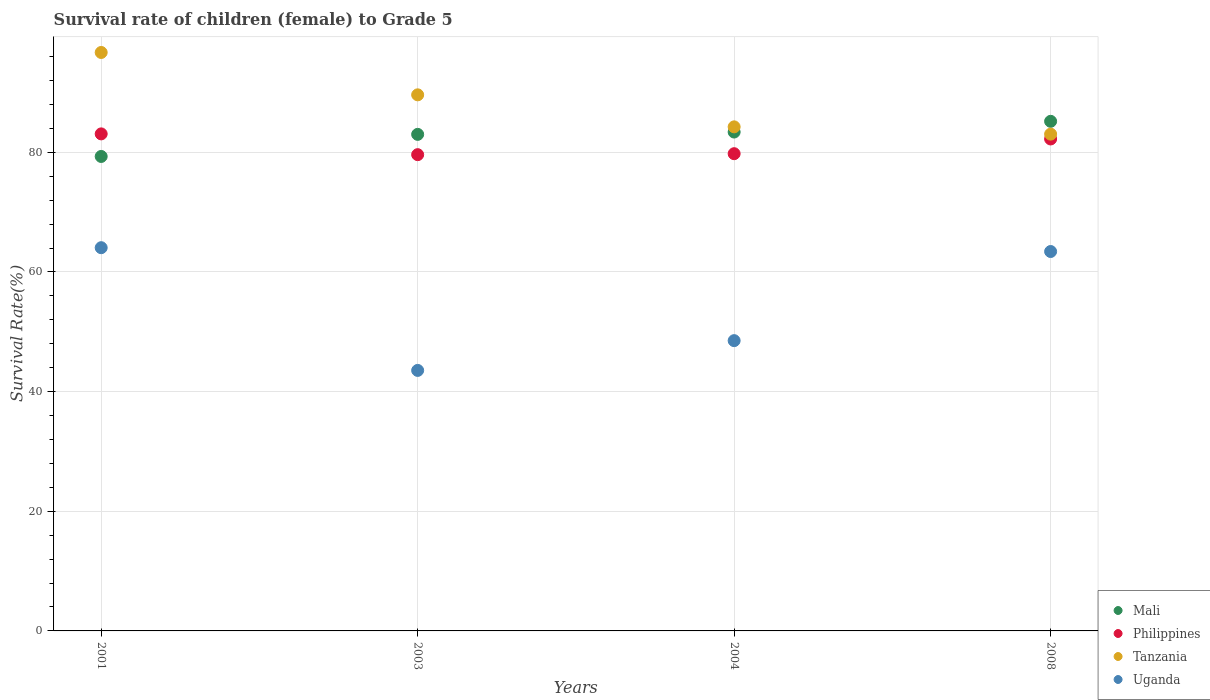How many different coloured dotlines are there?
Your response must be concise. 4. What is the survival rate of female children to grade 5 in Tanzania in 2008?
Offer a very short reply. 83.03. Across all years, what is the maximum survival rate of female children to grade 5 in Mali?
Make the answer very short. 85.18. Across all years, what is the minimum survival rate of female children to grade 5 in Philippines?
Provide a short and direct response. 79.6. In which year was the survival rate of female children to grade 5 in Uganda minimum?
Ensure brevity in your answer.  2003. What is the total survival rate of female children to grade 5 in Uganda in the graph?
Keep it short and to the point. 219.53. What is the difference between the survival rate of female children to grade 5 in Tanzania in 2003 and that in 2008?
Your response must be concise. 6.57. What is the difference between the survival rate of female children to grade 5 in Philippines in 2004 and the survival rate of female children to grade 5 in Uganda in 2003?
Provide a short and direct response. 36.22. What is the average survival rate of female children to grade 5 in Uganda per year?
Ensure brevity in your answer.  54.88. In the year 2003, what is the difference between the survival rate of female children to grade 5 in Tanzania and survival rate of female children to grade 5 in Mali?
Offer a terse response. 6.61. What is the ratio of the survival rate of female children to grade 5 in Uganda in 2004 to that in 2008?
Your answer should be very brief. 0.77. Is the survival rate of female children to grade 5 in Tanzania in 2003 less than that in 2004?
Offer a terse response. No. Is the difference between the survival rate of female children to grade 5 in Tanzania in 2001 and 2004 greater than the difference between the survival rate of female children to grade 5 in Mali in 2001 and 2004?
Your answer should be very brief. Yes. What is the difference between the highest and the second highest survival rate of female children to grade 5 in Uganda?
Your answer should be compact. 0.64. What is the difference between the highest and the lowest survival rate of female children to grade 5 in Philippines?
Your answer should be compact. 3.47. In how many years, is the survival rate of female children to grade 5 in Uganda greater than the average survival rate of female children to grade 5 in Uganda taken over all years?
Ensure brevity in your answer.  2. Is it the case that in every year, the sum of the survival rate of female children to grade 5 in Philippines and survival rate of female children to grade 5 in Uganda  is greater than the survival rate of female children to grade 5 in Mali?
Provide a short and direct response. Yes. Is the survival rate of female children to grade 5 in Uganda strictly less than the survival rate of female children to grade 5 in Tanzania over the years?
Make the answer very short. Yes. How many dotlines are there?
Make the answer very short. 4. How many years are there in the graph?
Your response must be concise. 4. What is the difference between two consecutive major ticks on the Y-axis?
Offer a terse response. 20. Are the values on the major ticks of Y-axis written in scientific E-notation?
Provide a short and direct response. No. How many legend labels are there?
Provide a succinct answer. 4. What is the title of the graph?
Give a very brief answer. Survival rate of children (female) to Grade 5. Does "Mauritius" appear as one of the legend labels in the graph?
Provide a short and direct response. No. What is the label or title of the X-axis?
Keep it short and to the point. Years. What is the label or title of the Y-axis?
Offer a terse response. Survival Rate(%). What is the Survival Rate(%) in Mali in 2001?
Your answer should be compact. 79.3. What is the Survival Rate(%) of Philippines in 2001?
Offer a very short reply. 83.08. What is the Survival Rate(%) of Tanzania in 2001?
Give a very brief answer. 96.68. What is the Survival Rate(%) in Uganda in 2001?
Offer a very short reply. 64.05. What is the Survival Rate(%) in Mali in 2003?
Your answer should be very brief. 83. What is the Survival Rate(%) in Philippines in 2003?
Give a very brief answer. 79.6. What is the Survival Rate(%) in Tanzania in 2003?
Offer a terse response. 89.6. What is the Survival Rate(%) in Uganda in 2003?
Provide a succinct answer. 43.54. What is the Survival Rate(%) of Mali in 2004?
Give a very brief answer. 83.38. What is the Survival Rate(%) in Philippines in 2004?
Offer a terse response. 79.77. What is the Survival Rate(%) of Tanzania in 2004?
Offer a terse response. 84.25. What is the Survival Rate(%) in Uganda in 2004?
Keep it short and to the point. 48.52. What is the Survival Rate(%) in Mali in 2008?
Provide a succinct answer. 85.18. What is the Survival Rate(%) of Philippines in 2008?
Your response must be concise. 82.23. What is the Survival Rate(%) in Tanzania in 2008?
Give a very brief answer. 83.03. What is the Survival Rate(%) in Uganda in 2008?
Ensure brevity in your answer.  63.41. Across all years, what is the maximum Survival Rate(%) in Mali?
Provide a succinct answer. 85.18. Across all years, what is the maximum Survival Rate(%) of Philippines?
Offer a terse response. 83.08. Across all years, what is the maximum Survival Rate(%) in Tanzania?
Offer a terse response. 96.68. Across all years, what is the maximum Survival Rate(%) in Uganda?
Your answer should be very brief. 64.05. Across all years, what is the minimum Survival Rate(%) of Mali?
Offer a terse response. 79.3. Across all years, what is the minimum Survival Rate(%) in Philippines?
Provide a short and direct response. 79.6. Across all years, what is the minimum Survival Rate(%) of Tanzania?
Your answer should be very brief. 83.03. Across all years, what is the minimum Survival Rate(%) of Uganda?
Offer a terse response. 43.54. What is the total Survival Rate(%) in Mali in the graph?
Your answer should be compact. 330.86. What is the total Survival Rate(%) of Philippines in the graph?
Give a very brief answer. 324.67. What is the total Survival Rate(%) in Tanzania in the graph?
Provide a short and direct response. 353.57. What is the total Survival Rate(%) in Uganda in the graph?
Your answer should be compact. 219.53. What is the difference between the Survival Rate(%) in Mali in 2001 and that in 2003?
Ensure brevity in your answer.  -3.69. What is the difference between the Survival Rate(%) of Philippines in 2001 and that in 2003?
Your response must be concise. 3.47. What is the difference between the Survival Rate(%) in Tanzania in 2001 and that in 2003?
Offer a very short reply. 7.08. What is the difference between the Survival Rate(%) of Uganda in 2001 and that in 2003?
Give a very brief answer. 20.51. What is the difference between the Survival Rate(%) in Mali in 2001 and that in 2004?
Offer a very short reply. -4.08. What is the difference between the Survival Rate(%) of Philippines in 2001 and that in 2004?
Make the answer very short. 3.31. What is the difference between the Survival Rate(%) of Tanzania in 2001 and that in 2004?
Provide a short and direct response. 12.43. What is the difference between the Survival Rate(%) of Uganda in 2001 and that in 2004?
Make the answer very short. 15.54. What is the difference between the Survival Rate(%) in Mali in 2001 and that in 2008?
Make the answer very short. -5.87. What is the difference between the Survival Rate(%) of Philippines in 2001 and that in 2008?
Your answer should be very brief. 0.85. What is the difference between the Survival Rate(%) in Tanzania in 2001 and that in 2008?
Offer a very short reply. 13.65. What is the difference between the Survival Rate(%) in Uganda in 2001 and that in 2008?
Offer a terse response. 0.64. What is the difference between the Survival Rate(%) of Mali in 2003 and that in 2004?
Ensure brevity in your answer.  -0.39. What is the difference between the Survival Rate(%) of Philippines in 2003 and that in 2004?
Your answer should be compact. -0.16. What is the difference between the Survival Rate(%) of Tanzania in 2003 and that in 2004?
Your answer should be very brief. 5.35. What is the difference between the Survival Rate(%) in Uganda in 2003 and that in 2004?
Your answer should be very brief. -4.98. What is the difference between the Survival Rate(%) in Mali in 2003 and that in 2008?
Offer a terse response. -2.18. What is the difference between the Survival Rate(%) in Philippines in 2003 and that in 2008?
Your answer should be compact. -2.62. What is the difference between the Survival Rate(%) of Tanzania in 2003 and that in 2008?
Offer a very short reply. 6.57. What is the difference between the Survival Rate(%) of Uganda in 2003 and that in 2008?
Give a very brief answer. -19.87. What is the difference between the Survival Rate(%) of Mali in 2004 and that in 2008?
Keep it short and to the point. -1.79. What is the difference between the Survival Rate(%) in Philippines in 2004 and that in 2008?
Keep it short and to the point. -2.46. What is the difference between the Survival Rate(%) in Tanzania in 2004 and that in 2008?
Offer a very short reply. 1.22. What is the difference between the Survival Rate(%) in Uganda in 2004 and that in 2008?
Your response must be concise. -14.9. What is the difference between the Survival Rate(%) of Mali in 2001 and the Survival Rate(%) of Philippines in 2003?
Keep it short and to the point. -0.3. What is the difference between the Survival Rate(%) of Mali in 2001 and the Survival Rate(%) of Tanzania in 2003?
Your answer should be compact. -10.3. What is the difference between the Survival Rate(%) of Mali in 2001 and the Survival Rate(%) of Uganda in 2003?
Your response must be concise. 35.76. What is the difference between the Survival Rate(%) of Philippines in 2001 and the Survival Rate(%) of Tanzania in 2003?
Offer a terse response. -6.53. What is the difference between the Survival Rate(%) of Philippines in 2001 and the Survival Rate(%) of Uganda in 2003?
Provide a succinct answer. 39.53. What is the difference between the Survival Rate(%) of Tanzania in 2001 and the Survival Rate(%) of Uganda in 2003?
Make the answer very short. 53.14. What is the difference between the Survival Rate(%) of Mali in 2001 and the Survival Rate(%) of Philippines in 2004?
Your answer should be very brief. -0.46. What is the difference between the Survival Rate(%) in Mali in 2001 and the Survival Rate(%) in Tanzania in 2004?
Your answer should be very brief. -4.95. What is the difference between the Survival Rate(%) of Mali in 2001 and the Survival Rate(%) of Uganda in 2004?
Provide a succinct answer. 30.78. What is the difference between the Survival Rate(%) of Philippines in 2001 and the Survival Rate(%) of Tanzania in 2004?
Provide a succinct answer. -1.18. What is the difference between the Survival Rate(%) in Philippines in 2001 and the Survival Rate(%) in Uganda in 2004?
Your answer should be compact. 34.56. What is the difference between the Survival Rate(%) of Tanzania in 2001 and the Survival Rate(%) of Uganda in 2004?
Give a very brief answer. 48.17. What is the difference between the Survival Rate(%) in Mali in 2001 and the Survival Rate(%) in Philippines in 2008?
Provide a short and direct response. -2.92. What is the difference between the Survival Rate(%) of Mali in 2001 and the Survival Rate(%) of Tanzania in 2008?
Offer a very short reply. -3.73. What is the difference between the Survival Rate(%) in Mali in 2001 and the Survival Rate(%) in Uganda in 2008?
Keep it short and to the point. 15.89. What is the difference between the Survival Rate(%) of Philippines in 2001 and the Survival Rate(%) of Tanzania in 2008?
Provide a succinct answer. 0.04. What is the difference between the Survival Rate(%) of Philippines in 2001 and the Survival Rate(%) of Uganda in 2008?
Provide a short and direct response. 19.66. What is the difference between the Survival Rate(%) in Tanzania in 2001 and the Survival Rate(%) in Uganda in 2008?
Provide a succinct answer. 33.27. What is the difference between the Survival Rate(%) of Mali in 2003 and the Survival Rate(%) of Philippines in 2004?
Give a very brief answer. 3.23. What is the difference between the Survival Rate(%) in Mali in 2003 and the Survival Rate(%) in Tanzania in 2004?
Give a very brief answer. -1.26. What is the difference between the Survival Rate(%) in Mali in 2003 and the Survival Rate(%) in Uganda in 2004?
Keep it short and to the point. 34.48. What is the difference between the Survival Rate(%) of Philippines in 2003 and the Survival Rate(%) of Tanzania in 2004?
Provide a succinct answer. -4.65. What is the difference between the Survival Rate(%) of Philippines in 2003 and the Survival Rate(%) of Uganda in 2004?
Provide a succinct answer. 31.09. What is the difference between the Survival Rate(%) in Tanzania in 2003 and the Survival Rate(%) in Uganda in 2004?
Your answer should be compact. 41.09. What is the difference between the Survival Rate(%) in Mali in 2003 and the Survival Rate(%) in Philippines in 2008?
Offer a very short reply. 0.77. What is the difference between the Survival Rate(%) of Mali in 2003 and the Survival Rate(%) of Tanzania in 2008?
Ensure brevity in your answer.  -0.04. What is the difference between the Survival Rate(%) of Mali in 2003 and the Survival Rate(%) of Uganda in 2008?
Keep it short and to the point. 19.58. What is the difference between the Survival Rate(%) in Philippines in 2003 and the Survival Rate(%) in Tanzania in 2008?
Your answer should be compact. -3.43. What is the difference between the Survival Rate(%) in Philippines in 2003 and the Survival Rate(%) in Uganda in 2008?
Your answer should be compact. 16.19. What is the difference between the Survival Rate(%) of Tanzania in 2003 and the Survival Rate(%) of Uganda in 2008?
Your answer should be very brief. 26.19. What is the difference between the Survival Rate(%) in Mali in 2004 and the Survival Rate(%) in Philippines in 2008?
Your answer should be very brief. 1.16. What is the difference between the Survival Rate(%) of Mali in 2004 and the Survival Rate(%) of Tanzania in 2008?
Offer a terse response. 0.35. What is the difference between the Survival Rate(%) of Mali in 2004 and the Survival Rate(%) of Uganda in 2008?
Offer a terse response. 19.97. What is the difference between the Survival Rate(%) of Philippines in 2004 and the Survival Rate(%) of Tanzania in 2008?
Provide a succinct answer. -3.27. What is the difference between the Survival Rate(%) of Philippines in 2004 and the Survival Rate(%) of Uganda in 2008?
Your answer should be very brief. 16.35. What is the difference between the Survival Rate(%) in Tanzania in 2004 and the Survival Rate(%) in Uganda in 2008?
Provide a short and direct response. 20.84. What is the average Survival Rate(%) in Mali per year?
Ensure brevity in your answer.  82.71. What is the average Survival Rate(%) in Philippines per year?
Keep it short and to the point. 81.17. What is the average Survival Rate(%) of Tanzania per year?
Offer a terse response. 88.39. What is the average Survival Rate(%) in Uganda per year?
Your response must be concise. 54.88. In the year 2001, what is the difference between the Survival Rate(%) in Mali and Survival Rate(%) in Philippines?
Your answer should be compact. -3.77. In the year 2001, what is the difference between the Survival Rate(%) of Mali and Survival Rate(%) of Tanzania?
Provide a succinct answer. -17.38. In the year 2001, what is the difference between the Survival Rate(%) of Mali and Survival Rate(%) of Uganda?
Give a very brief answer. 15.25. In the year 2001, what is the difference between the Survival Rate(%) of Philippines and Survival Rate(%) of Tanzania?
Offer a very short reply. -13.61. In the year 2001, what is the difference between the Survival Rate(%) of Philippines and Survival Rate(%) of Uganda?
Keep it short and to the point. 19.02. In the year 2001, what is the difference between the Survival Rate(%) in Tanzania and Survival Rate(%) in Uganda?
Keep it short and to the point. 32.63. In the year 2003, what is the difference between the Survival Rate(%) in Mali and Survival Rate(%) in Philippines?
Your answer should be compact. 3.39. In the year 2003, what is the difference between the Survival Rate(%) of Mali and Survival Rate(%) of Tanzania?
Provide a short and direct response. -6.61. In the year 2003, what is the difference between the Survival Rate(%) of Mali and Survival Rate(%) of Uganda?
Your answer should be compact. 39.45. In the year 2003, what is the difference between the Survival Rate(%) of Philippines and Survival Rate(%) of Tanzania?
Offer a very short reply. -10. In the year 2003, what is the difference between the Survival Rate(%) of Philippines and Survival Rate(%) of Uganda?
Offer a very short reply. 36.06. In the year 2003, what is the difference between the Survival Rate(%) of Tanzania and Survival Rate(%) of Uganda?
Offer a terse response. 46.06. In the year 2004, what is the difference between the Survival Rate(%) in Mali and Survival Rate(%) in Philippines?
Your answer should be compact. 3.62. In the year 2004, what is the difference between the Survival Rate(%) of Mali and Survival Rate(%) of Tanzania?
Provide a succinct answer. -0.87. In the year 2004, what is the difference between the Survival Rate(%) in Mali and Survival Rate(%) in Uganda?
Offer a very short reply. 34.87. In the year 2004, what is the difference between the Survival Rate(%) of Philippines and Survival Rate(%) of Tanzania?
Keep it short and to the point. -4.49. In the year 2004, what is the difference between the Survival Rate(%) of Philippines and Survival Rate(%) of Uganda?
Give a very brief answer. 31.25. In the year 2004, what is the difference between the Survival Rate(%) in Tanzania and Survival Rate(%) in Uganda?
Ensure brevity in your answer.  35.73. In the year 2008, what is the difference between the Survival Rate(%) in Mali and Survival Rate(%) in Philippines?
Keep it short and to the point. 2.95. In the year 2008, what is the difference between the Survival Rate(%) of Mali and Survival Rate(%) of Tanzania?
Provide a short and direct response. 2.14. In the year 2008, what is the difference between the Survival Rate(%) in Mali and Survival Rate(%) in Uganda?
Ensure brevity in your answer.  21.76. In the year 2008, what is the difference between the Survival Rate(%) of Philippines and Survival Rate(%) of Tanzania?
Give a very brief answer. -0.81. In the year 2008, what is the difference between the Survival Rate(%) of Philippines and Survival Rate(%) of Uganda?
Keep it short and to the point. 18.81. In the year 2008, what is the difference between the Survival Rate(%) of Tanzania and Survival Rate(%) of Uganda?
Your answer should be compact. 19.62. What is the ratio of the Survival Rate(%) of Mali in 2001 to that in 2003?
Your answer should be very brief. 0.96. What is the ratio of the Survival Rate(%) in Philippines in 2001 to that in 2003?
Ensure brevity in your answer.  1.04. What is the ratio of the Survival Rate(%) in Tanzania in 2001 to that in 2003?
Offer a very short reply. 1.08. What is the ratio of the Survival Rate(%) of Uganda in 2001 to that in 2003?
Make the answer very short. 1.47. What is the ratio of the Survival Rate(%) of Mali in 2001 to that in 2004?
Give a very brief answer. 0.95. What is the ratio of the Survival Rate(%) of Philippines in 2001 to that in 2004?
Provide a succinct answer. 1.04. What is the ratio of the Survival Rate(%) of Tanzania in 2001 to that in 2004?
Make the answer very short. 1.15. What is the ratio of the Survival Rate(%) in Uganda in 2001 to that in 2004?
Give a very brief answer. 1.32. What is the ratio of the Survival Rate(%) in Philippines in 2001 to that in 2008?
Make the answer very short. 1.01. What is the ratio of the Survival Rate(%) in Tanzania in 2001 to that in 2008?
Ensure brevity in your answer.  1.16. What is the ratio of the Survival Rate(%) of Tanzania in 2003 to that in 2004?
Your response must be concise. 1.06. What is the ratio of the Survival Rate(%) of Uganda in 2003 to that in 2004?
Your answer should be compact. 0.9. What is the ratio of the Survival Rate(%) of Mali in 2003 to that in 2008?
Ensure brevity in your answer.  0.97. What is the ratio of the Survival Rate(%) in Philippines in 2003 to that in 2008?
Offer a very short reply. 0.97. What is the ratio of the Survival Rate(%) of Tanzania in 2003 to that in 2008?
Keep it short and to the point. 1.08. What is the ratio of the Survival Rate(%) in Uganda in 2003 to that in 2008?
Ensure brevity in your answer.  0.69. What is the ratio of the Survival Rate(%) of Philippines in 2004 to that in 2008?
Keep it short and to the point. 0.97. What is the ratio of the Survival Rate(%) of Tanzania in 2004 to that in 2008?
Your answer should be compact. 1.01. What is the ratio of the Survival Rate(%) in Uganda in 2004 to that in 2008?
Provide a succinct answer. 0.77. What is the difference between the highest and the second highest Survival Rate(%) in Mali?
Provide a succinct answer. 1.79. What is the difference between the highest and the second highest Survival Rate(%) in Philippines?
Offer a terse response. 0.85. What is the difference between the highest and the second highest Survival Rate(%) of Tanzania?
Your answer should be very brief. 7.08. What is the difference between the highest and the second highest Survival Rate(%) in Uganda?
Offer a very short reply. 0.64. What is the difference between the highest and the lowest Survival Rate(%) of Mali?
Your answer should be very brief. 5.87. What is the difference between the highest and the lowest Survival Rate(%) in Philippines?
Make the answer very short. 3.47. What is the difference between the highest and the lowest Survival Rate(%) of Tanzania?
Make the answer very short. 13.65. What is the difference between the highest and the lowest Survival Rate(%) of Uganda?
Provide a succinct answer. 20.51. 